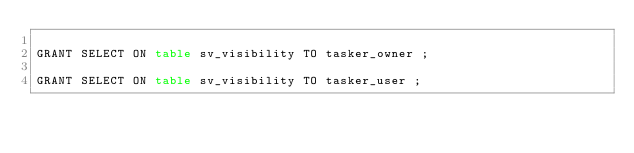Convert code to text. <code><loc_0><loc_0><loc_500><loc_500><_SQL_>
GRANT SELECT ON table sv_visibility TO tasker_owner ;

GRANT SELECT ON table sv_visibility TO tasker_user ;
</code> 